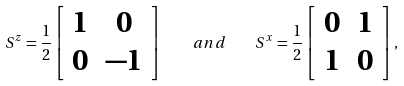Convert formula to latex. <formula><loc_0><loc_0><loc_500><loc_500>S ^ { z } = \frac { 1 } { 2 } \left [ \begin{array} { c c } 1 & 0 \\ 0 & - 1 \end{array} \right ] \quad a n d \quad S ^ { x } = \frac { 1 } { 2 } \left [ \begin{array} { c c } 0 & 1 \\ 1 & 0 \end{array} \right ] ,</formula> 